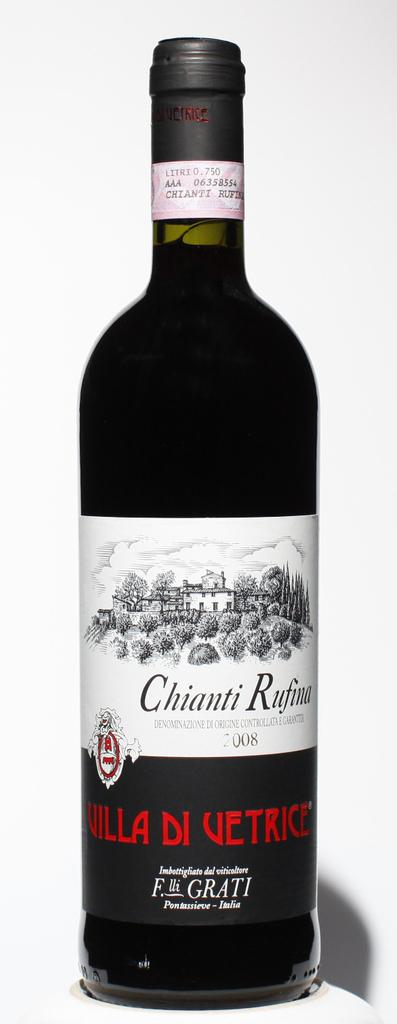<image>
Give a short and clear explanation of the subsequent image. A bottle of Chianti Rufina stands upright and unopened. 